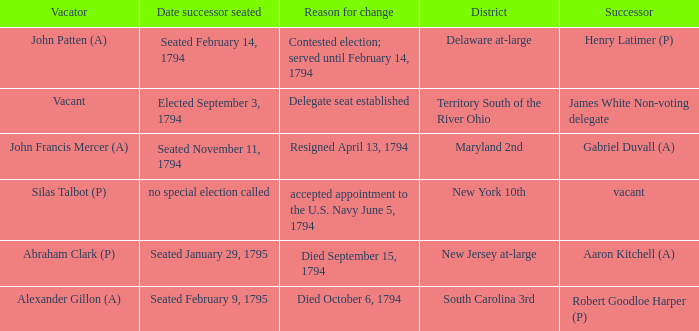Name the date successor seated for contested election; served until february 14, 1794 Seated February 14, 1794. 